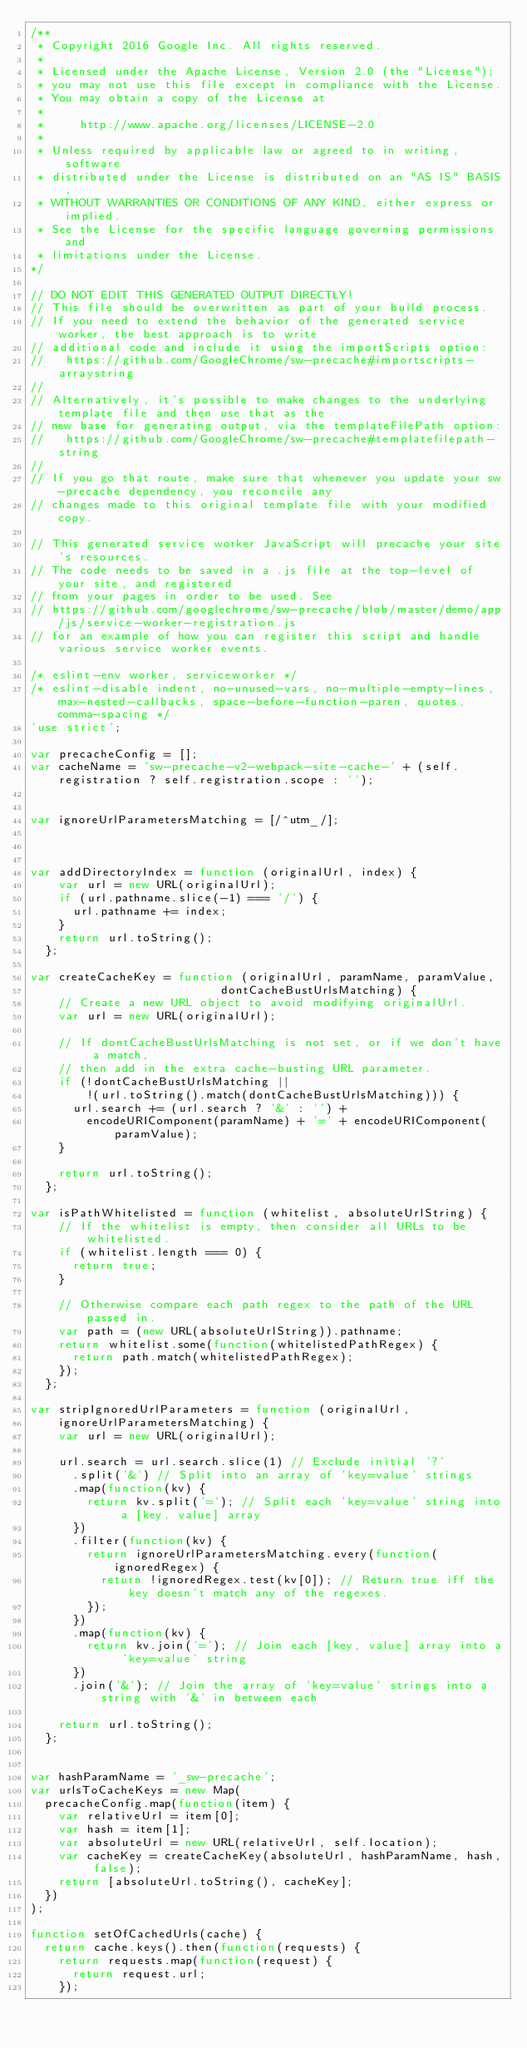Convert code to text. <code><loc_0><loc_0><loc_500><loc_500><_JavaScript_>/**
 * Copyright 2016 Google Inc. All rights reserved.
 *
 * Licensed under the Apache License, Version 2.0 (the "License");
 * you may not use this file except in compliance with the License.
 * You may obtain a copy of the License at
 *
 *     http://www.apache.org/licenses/LICENSE-2.0
 *
 * Unless required by applicable law or agreed to in writing, software
 * distributed under the License is distributed on an "AS IS" BASIS,
 * WITHOUT WARRANTIES OR CONDITIONS OF ANY KIND, either express or implied.
 * See the License for the specific language governing permissions and
 * limitations under the License.
*/

// DO NOT EDIT THIS GENERATED OUTPUT DIRECTLY!
// This file should be overwritten as part of your build process.
// If you need to extend the behavior of the generated service worker, the best approach is to write
// additional code and include it using the importScripts option:
//   https://github.com/GoogleChrome/sw-precache#importscripts-arraystring
//
// Alternatively, it's possible to make changes to the underlying template file and then use that as the
// new base for generating output, via the templateFilePath option:
//   https://github.com/GoogleChrome/sw-precache#templatefilepath-string
//
// If you go that route, make sure that whenever you update your sw-precache dependency, you reconcile any
// changes made to this original template file with your modified copy.

// This generated service worker JavaScript will precache your site's resources.
// The code needs to be saved in a .js file at the top-level of your site, and registered
// from your pages in order to be used. See
// https://github.com/googlechrome/sw-precache/blob/master/demo/app/js/service-worker-registration.js
// for an example of how you can register this script and handle various service worker events.

/* eslint-env worker, serviceworker */
/* eslint-disable indent, no-unused-vars, no-multiple-empty-lines, max-nested-callbacks, space-before-function-paren, quotes, comma-spacing */
'use strict';

var precacheConfig = [];
var cacheName = 'sw-precache-v2-webpack-site-cache-' + (self.registration ? self.registration.scope : '');


var ignoreUrlParametersMatching = [/^utm_/];



var addDirectoryIndex = function (originalUrl, index) {
    var url = new URL(originalUrl);
    if (url.pathname.slice(-1) === '/') {
      url.pathname += index;
    }
    return url.toString();
  };

var createCacheKey = function (originalUrl, paramName, paramValue,
                           dontCacheBustUrlsMatching) {
    // Create a new URL object to avoid modifying originalUrl.
    var url = new URL(originalUrl);

    // If dontCacheBustUrlsMatching is not set, or if we don't have a match,
    // then add in the extra cache-busting URL parameter.
    if (!dontCacheBustUrlsMatching ||
        !(url.toString().match(dontCacheBustUrlsMatching))) {
      url.search += (url.search ? '&' : '') +
        encodeURIComponent(paramName) + '=' + encodeURIComponent(paramValue);
    }

    return url.toString();
  };

var isPathWhitelisted = function (whitelist, absoluteUrlString) {
    // If the whitelist is empty, then consider all URLs to be whitelisted.
    if (whitelist.length === 0) {
      return true;
    }

    // Otherwise compare each path regex to the path of the URL passed in.
    var path = (new URL(absoluteUrlString)).pathname;
    return whitelist.some(function(whitelistedPathRegex) {
      return path.match(whitelistedPathRegex);
    });
  };

var stripIgnoredUrlParameters = function (originalUrl,
    ignoreUrlParametersMatching) {
    var url = new URL(originalUrl);

    url.search = url.search.slice(1) // Exclude initial '?'
      .split('&') // Split into an array of 'key=value' strings
      .map(function(kv) {
        return kv.split('='); // Split each 'key=value' string into a [key, value] array
      })
      .filter(function(kv) {
        return ignoreUrlParametersMatching.every(function(ignoredRegex) {
          return !ignoredRegex.test(kv[0]); // Return true iff the key doesn't match any of the regexes.
        });
      })
      .map(function(kv) {
        return kv.join('='); // Join each [key, value] array into a 'key=value' string
      })
      .join('&'); // Join the array of 'key=value' strings into a string with '&' in between each

    return url.toString();
  };


var hashParamName = '_sw-precache';
var urlsToCacheKeys = new Map(
  precacheConfig.map(function(item) {
    var relativeUrl = item[0];
    var hash = item[1];
    var absoluteUrl = new URL(relativeUrl, self.location);
    var cacheKey = createCacheKey(absoluteUrl, hashParamName, hash, false);
    return [absoluteUrl.toString(), cacheKey];
  })
);

function setOfCachedUrls(cache) {
  return cache.keys().then(function(requests) {
    return requests.map(function(request) {
      return request.url;
    });</code> 